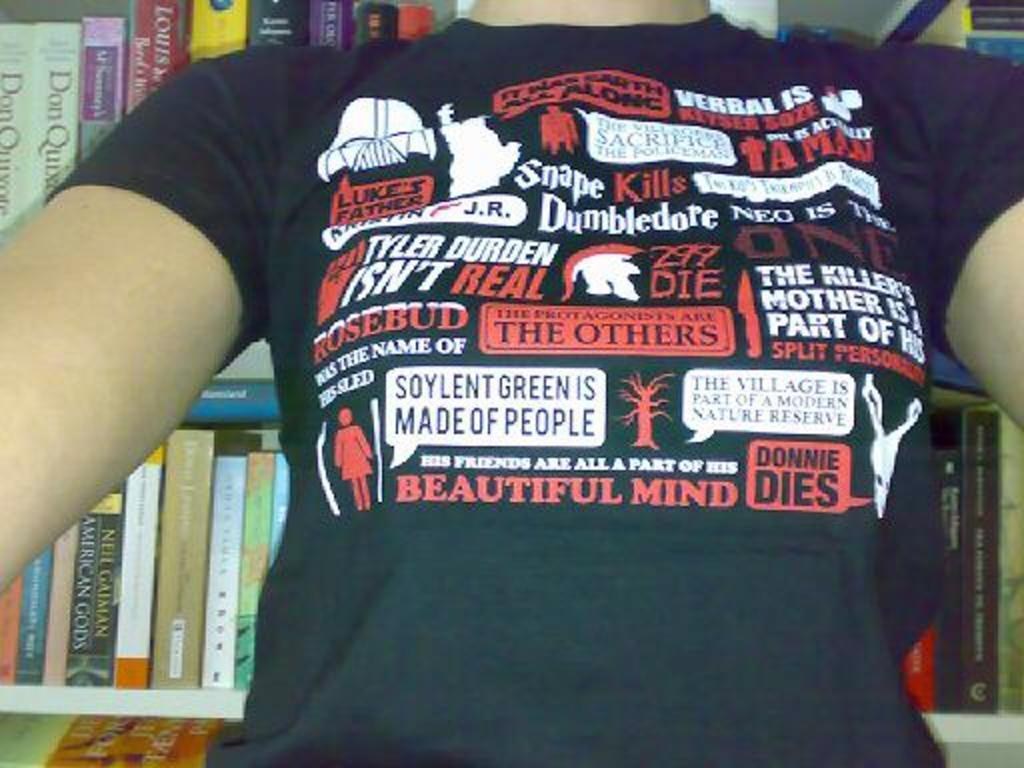<image>
Provide a brief description of the given image. A black shirt with phrases such as Donnie Dies and Dumbledore on it. 